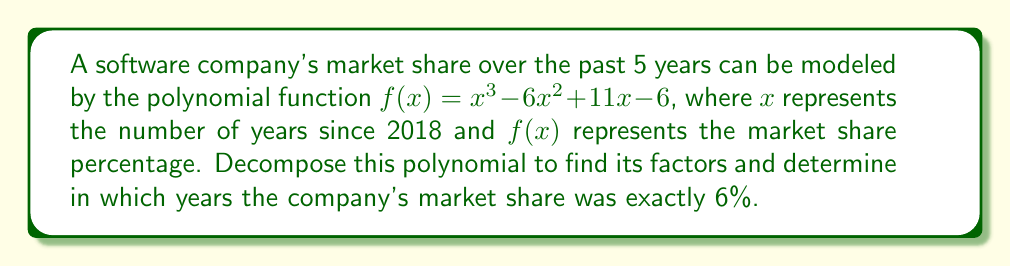Show me your answer to this math problem. To solve this problem, we need to factor the polynomial $f(x) = x^3 - 6x^2 + 11x - 6$ and find the roots of the equation $f(x) = 6$.

Step 1: Factor out the greatest common factor (GCF).
There is no common factor, so we proceed to the next step.

Step 2: Try to identify a rational root.
Using the rational root theorem, potential roots are factors of the constant term: ±1, ±2, ±3, ±6
Testing these values, we find that $f(1) = 0$. So $(x-1)$ is a factor.

Step 3: Use polynomial long division to find the other factor.
$x^3 - 6x^2 + 11x - 6 = (x-1)(x^2 - 5x + 6)$

Step 4: Factor the quadratic term.
$x^2 - 5x + 6 = (x-2)(x-3)$

Therefore, the fully factored polynomial is:
$f(x) = (x-1)(x-2)(x-3)$

Step 5: Solve the equation $f(x) = 6$.
$(x-1)(x-2)(x-3) = 6$

The left side equals 6 when $x = 1$, $x = 2$, or $x = 3$.

Step 6: Interpret the results.
$x = 1$ corresponds to 2019
$x = 2$ corresponds to 2020
$x = 3$ corresponds to 2021
Answer: $(x-1)(x-2)(x-3)$; 2019, 2020, and 2021 